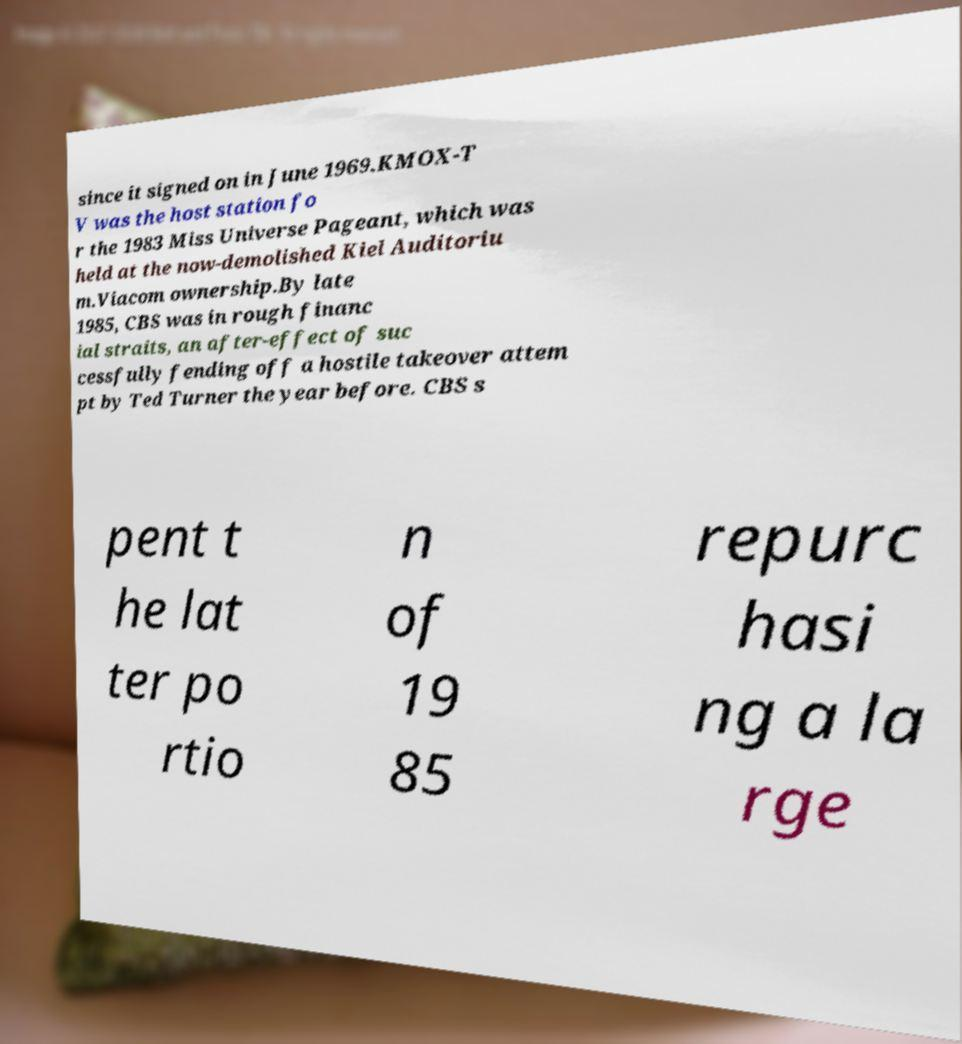Could you assist in decoding the text presented in this image and type it out clearly? since it signed on in June 1969.KMOX-T V was the host station fo r the 1983 Miss Universe Pageant, which was held at the now-demolished Kiel Auditoriu m.Viacom ownership.By late 1985, CBS was in rough financ ial straits, an after-effect of suc cessfully fending off a hostile takeover attem pt by Ted Turner the year before. CBS s pent t he lat ter po rtio n of 19 85 repurc hasi ng a la rge 